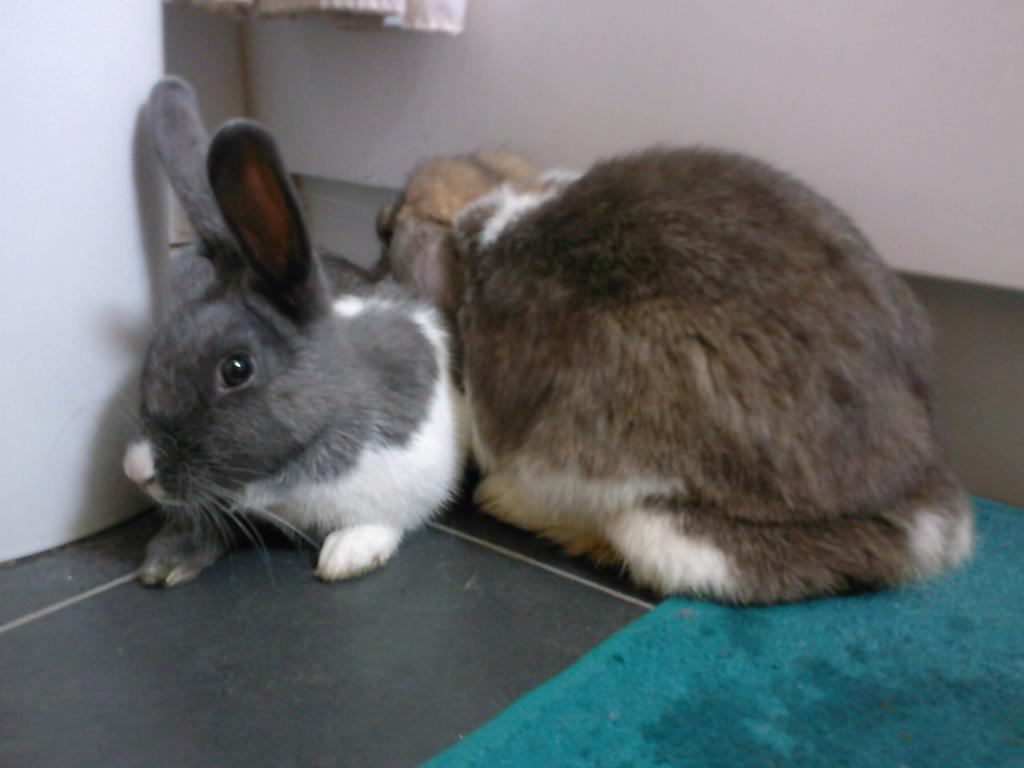What animals are present in the image? There are rabbits in the image. Where are the rabbits located? The rabbits are on the floor. What can be seen on the right side of the image? There is a floor mat on the right side of the image. What type of adjustment can be seen being made by the fairies in the image? There are no fairies present in the image, so no adjustments can be observed. 